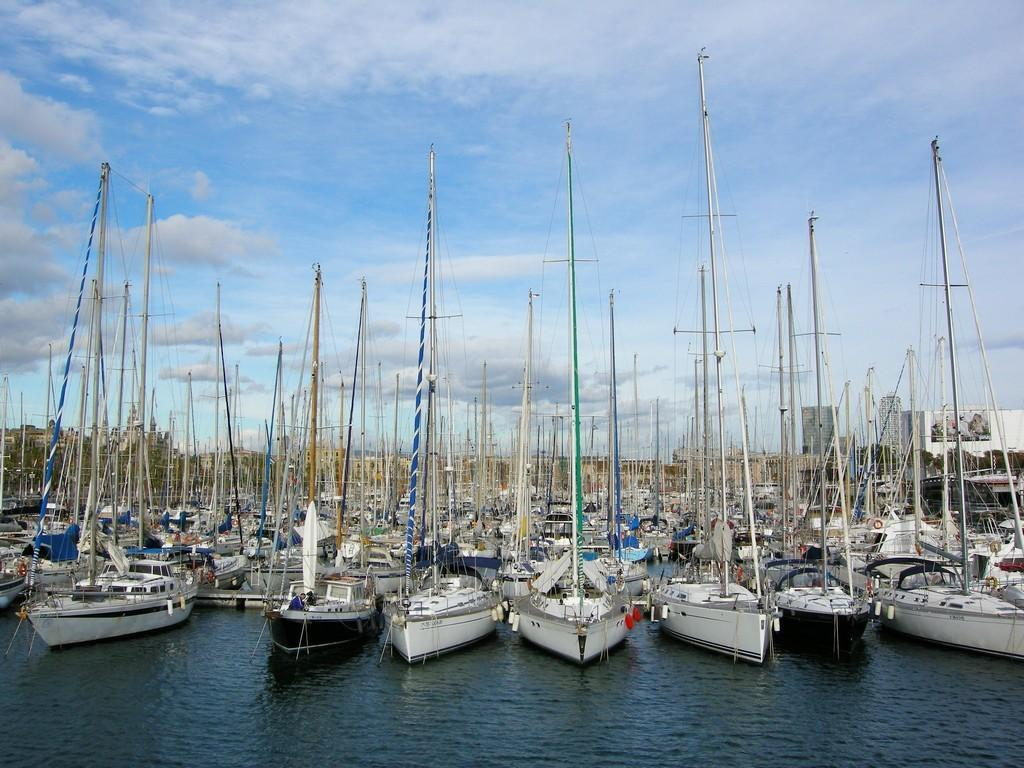What is in the water in the image? There are ships in the water in the image. What else can be seen in the image besides the ships? There are poles with strings in the image. What is visible in the background of the image? The sky is visible in the image. What can be observed in the sky? Clouds are present in the sky. What type of disgust can be seen on the branch in the image? There is no branch or disgust present in the image. How is the knife being used in the image? There is no knife present in the image. 